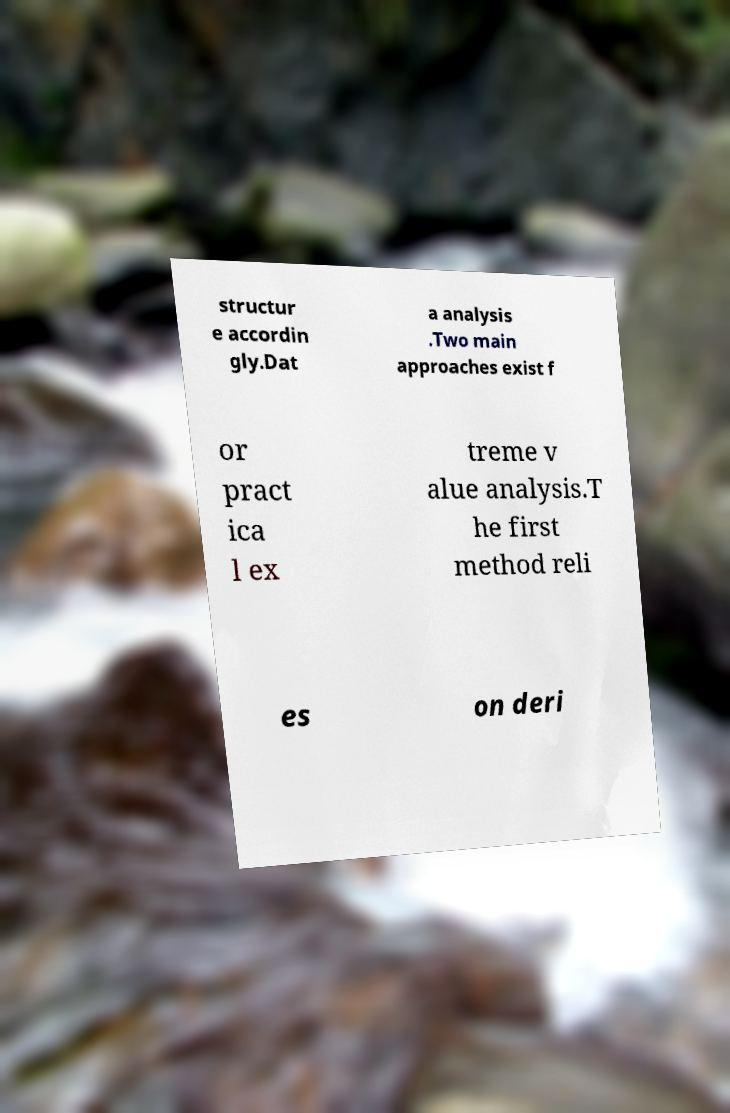I need the written content from this picture converted into text. Can you do that? structur e accordin gly.Dat a analysis .Two main approaches exist f or pract ica l ex treme v alue analysis.T he first method reli es on deri 